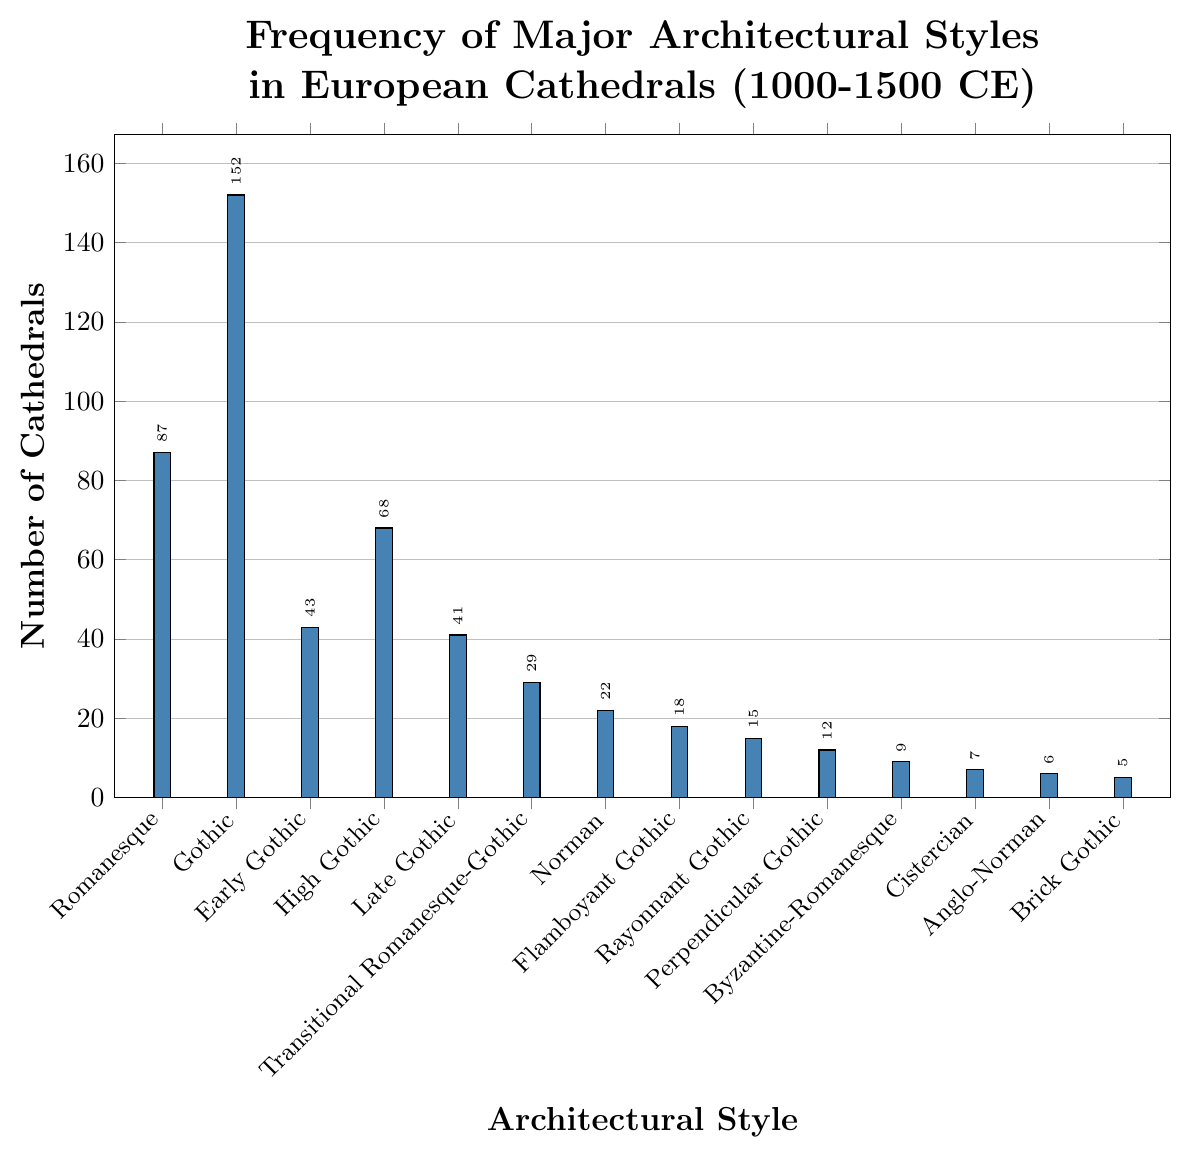Which architectural style has the highest number of cathedrals? The figure shows the number of cathedrals for each architectural style as bar heights. The tallest bar corresponds to the Gothic style. Therefore, Gothic has the highest number of cathedrals.
Answer: Gothic Which architectural style is the least common? The figure shows each architectural style's number of cathedrals. The shortest bar corresponds to Brick Gothic with just 5 cathedrals.
Answer: Brick Gothic How many more Gothic cathedrals are there compared to Early Gothic cathedrals? According to the figure, Gothic has 152 cathedrals, and Early Gothic has 43. Subtracting the latter from the former gives 152 - 43 = 109.
Answer: 109 How many cathedrals were built in the transitional period from Romanesque to Gothic? The bar labeled "Transitional Romanesque-Gothic" shows the number of cathedrals in this style, which is 29 according to the visual representation.
Answer: 29 What is the sum of cathedrals built in all Gothic sub-styles (Early, High, Late, Flamboyant, Rayonnant, Perpendicular)? The number of cathedrals for each sub-style is: Early Gothic (43), High Gothic (68), Late Gothic (41), Flamboyant Gothic (18), Rayonnant Gothic (15), Perpendicular Gothic (12). Summing these gives 43 + 68 + 41 + 18 + 15 + 12 = 197.
Answer: 197 Compare the number of Romanesque cathedrals versus Norman cathedrals. Which is more and by how much? Romanesque has 87 cathedrals while Norman has 22. To find the difference: 87 - 22 = 65. Romanesque has 65 more cathedrals than Norman.
Answer: 65 What proportion of total cathedrals does the Gothic style represent? First, find the total number of cathedrals by summing all styles: 87 + 152 + 43 + 68 + 41 + 29 + 22 + 18 + 15 + 12 + 9 + 7 + 6 + 5 = 514. Then, calculate the proportion for Gothic: 152 / 514. This equals approximately 0.296 or 29.6%.
Answer: 29.6% Which color represents the bars in the figure? The bars in the figure are all colored. By visual inspection, the color used appears to be a shade of blue.
Answer: Blue Determine whether Cistercian or Anglo-Norman cathedrals are more common and by what margin. Cistercian cathedrals count is 7 while Anglo-Norman cathedrals count is 6. The difference is 7 - 6 = 1 cathedrals. Cistercian cathedrals are more common by 1.
Answer: 1 What are the total number of cathedrals represented in the figure? Sum all the cathedrals for each style to get the total: 87(Romanesque) + 152(Gothic) + 43(Early Gothic) + 68(High Gothic) + 41(Late Gothic) + 29(Transitional Romanesque-Gothic) + 22(Norman) + 18(Flamboyant Gothic) + 15(Rayonnant Gothic) + 12(Perpendicular Gothic) + 9(Byzantine-Romanesque) + 7(Cistercian) + 6(Anglo-Norman) + 5(Brick Gothic) = 514.
Answer: 514 